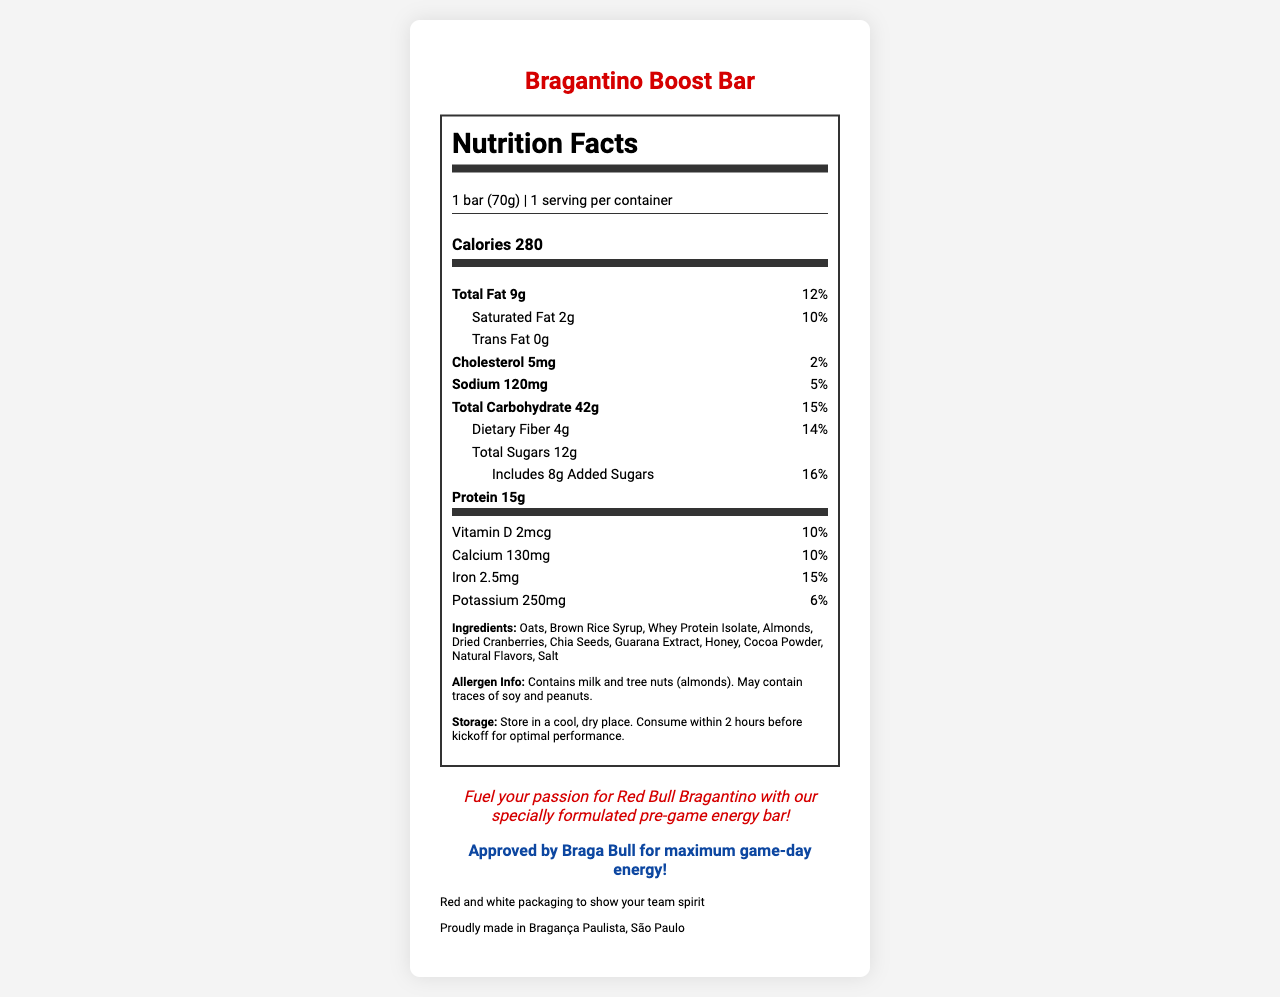what is the serving size of the Bragantino Boost Bar? The serving size is clearly stated at the top of the nutrition label as "1 bar (70g)".
Answer: 1 bar (70g) how much protein does the Bragantino Boost Bar contain? The amount of protein is listed in the 'Nutrient Row' section of the nutrition label.
Answer: 15g what percentage of the daily value of calcium is provided by the Bragantino Boost Bar? The daily value percentage for calcium is listed under the 'vitamins' section of the nutrition label.
Answer: 10% how much fiber is in the Bragantino Boost Bar? The amount of dietary fiber is listed in the nutrition label under total carbohydrates.
Answer: 4g what is the main carbohydrate source in the Bragantino Boost Bar? Oats are listed first in the ingredients, indicating they are the primary ingredient and the main source of carbohydrates.
Answer: Oats which of the following is not an ingredient in the Bragantino Boost Bar? A. Almonds B. Whey Protein Isolate C. Soy Protein D. Guarana Extract Soy Protein is not listed in the ingredients section of the label.
Answer: C. Soy Protein what is the total number of calories in the Bragantino Boost Bar? A. 200 B. 280 C. 300 D. 350 The total number of calories is prominently displayed in the 'Calorie Info' section as "Calories 280".
Answer: B. 280 does the Bragantino Boost Bar contain trans fat? Under the 'Total Fat' section, it is listed that the bar contains 0g of trans fat.
Answer: No is the Bragantino Boost Bar suitable for someone with a peanut allergy? The allergen information states that it may contain traces of peanuts.
Answer: No summarize the main idea of the Bragantino Boost Bar's nutrition label. The nutrition label provides detailed information on the bar's serving size, calorie content, macronutrient composition, vitamins, minerals, ingredients, and allergen information.
Answer: The Bragantino Boost Bar is a pre-game meal replacement bar designed to provide slow-release energy and balanced macronutrients suitable for consumption before sports activities. It contains proteins, carbohydrates, fats, essential vitamins, and minerals while being mindful of common allergens. how much added sugar is in the Bragantino Boost Bar? The amount of added sugars is listed in the 'Total Sugars' section of the nutrition label.
Answer: 8g where is the Bragantino Boost Bar made? The origin of the product is listed as "Proudly made in Bragança Paulista, São Paulo" at the bottom of the document.
Answer: Bragança Paulista, São Paulo how should the Bragantino Boost Bar be stored? The storage instructions are stated in the ingredients section and suggest storing the bar in a cool, dry place.
Answer: Store in a cool, dry place what is the total fat content in the Bragantino Boost Bar in terms of grams and daily value percentage? The total fat content is clearly stated as 9g and 12% of the daily value.
Answer: 9g, 12% how much potassium does the Bragantino Boost Bar provide? The amount of potassium is listed under the 'vitamins' section of the nutrition label.
Answer: 250mg does the Bragantino Boost Bar contain any vitamin C? The nutrition label does not mention vitamin C, thus it cannot be determined if the bar contains any vitamin C.
Answer: Not enough information how long before kickoff should the Bragantino Boost Bar be consumed? The storage instructions state to consume it within 2 hours before kickoff for optimal performance.
Answer: Within 2 hours what type of statement is, "Fuel your passion for Red Bull Bragantino with our specially formulated pre-game energy bar!" This is a brand statement as it describes the product's intent and connection to the Red Bull Bragantino team.
Answer: Brand statement is the Bragantino Boost Bar packaging themed in a specific way? The packaging is themed in red and white to show team spirit, as noted in the 'team colors' section.
Answer: Yes 